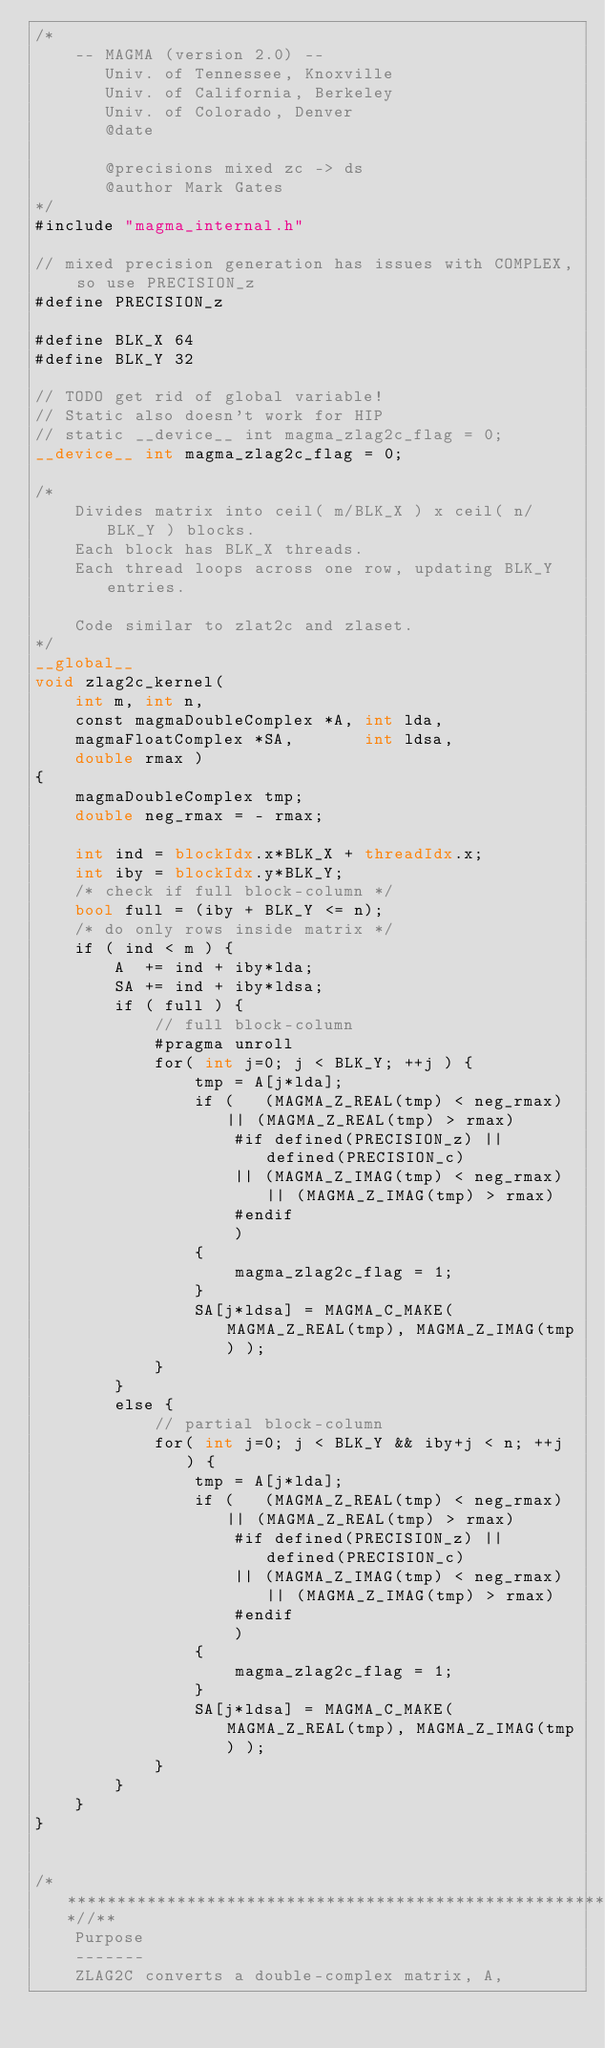Convert code to text. <code><loc_0><loc_0><loc_500><loc_500><_Cuda_>/*
    -- MAGMA (version 2.0) --
       Univ. of Tennessee, Knoxville
       Univ. of California, Berkeley
       Univ. of Colorado, Denver
       @date

       @precisions mixed zc -> ds
       @author Mark Gates
*/
#include "magma_internal.h"

// mixed precision generation has issues with COMPLEX, so use PRECISION_z
#define PRECISION_z

#define BLK_X 64
#define BLK_Y 32

// TODO get rid of global variable!
// Static also doesn't work for HIP
// static __device__ int magma_zlag2c_flag = 0;
__device__ int magma_zlag2c_flag = 0;

/*
    Divides matrix into ceil( m/BLK_X ) x ceil( n/BLK_Y ) blocks.
    Each block has BLK_X threads.
    Each thread loops across one row, updating BLK_Y entries.
    
    Code similar to zlat2c and zlaset.
*/
__global__
void zlag2c_kernel(
    int m, int n,
    const magmaDoubleComplex *A, int lda,
    magmaFloatComplex *SA,       int ldsa,
    double rmax )
{
    magmaDoubleComplex tmp;
    double neg_rmax = - rmax;
    
    int ind = blockIdx.x*BLK_X + threadIdx.x;
    int iby = blockIdx.y*BLK_Y;
    /* check if full block-column */
    bool full = (iby + BLK_Y <= n);
    /* do only rows inside matrix */
    if ( ind < m ) {
        A  += ind + iby*lda;
        SA += ind + iby*ldsa;
        if ( full ) {
            // full block-column
            #pragma unroll
            for( int j=0; j < BLK_Y; ++j ) {
                tmp = A[j*lda];
                if (   (MAGMA_Z_REAL(tmp) < neg_rmax) || (MAGMA_Z_REAL(tmp) > rmax)
                    #if defined(PRECISION_z) || defined(PRECISION_c)
                    || (MAGMA_Z_IMAG(tmp) < neg_rmax) || (MAGMA_Z_IMAG(tmp) > rmax)
                    #endif
                    )
                {
                    magma_zlag2c_flag = 1;
                }
                SA[j*ldsa] = MAGMA_C_MAKE( MAGMA_Z_REAL(tmp), MAGMA_Z_IMAG(tmp) );
            }
        }
        else {
            // partial block-column
            for( int j=0; j < BLK_Y && iby+j < n; ++j ) {
                tmp = A[j*lda];
                if (   (MAGMA_Z_REAL(tmp) < neg_rmax) || (MAGMA_Z_REAL(tmp) > rmax)
                    #if defined(PRECISION_z) || defined(PRECISION_c)
                    || (MAGMA_Z_IMAG(tmp) < neg_rmax) || (MAGMA_Z_IMAG(tmp) > rmax)
                    #endif
                    )
                {
                    magma_zlag2c_flag = 1;
                }
                SA[j*ldsa] = MAGMA_C_MAKE( MAGMA_Z_REAL(tmp), MAGMA_Z_IMAG(tmp) );
            }
        }
    }
}


/***************************************************************************//**
    Purpose
    -------
    ZLAG2C converts a double-complex matrix, A,</code> 